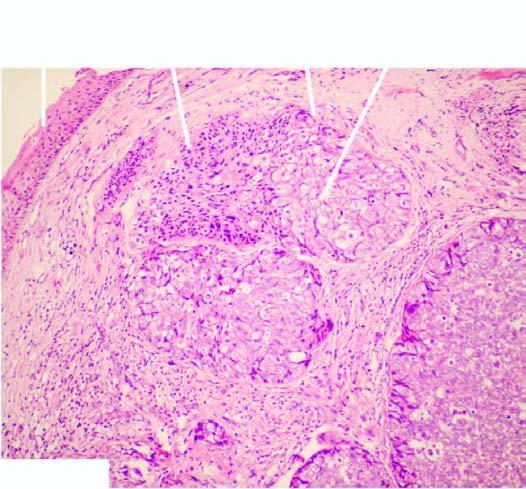what have sebaceous differentiation appreciated by foamy, vacuolated cytoplasm?
Answer the question using a single word or phrase. Cells 